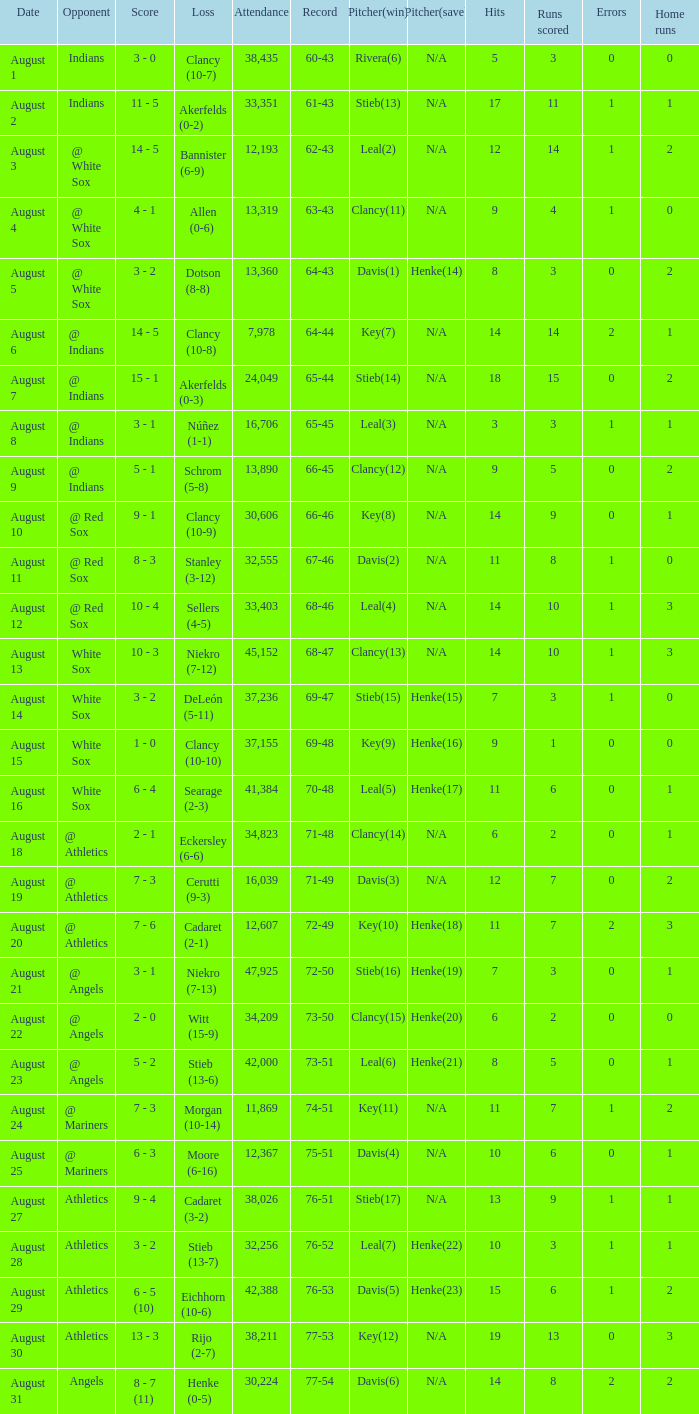What was the attendance when the record was 77-54? 30224.0. 